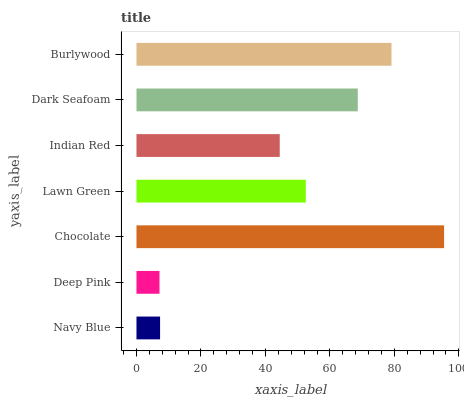Is Deep Pink the minimum?
Answer yes or no. Yes. Is Chocolate the maximum?
Answer yes or no. Yes. Is Chocolate the minimum?
Answer yes or no. No. Is Deep Pink the maximum?
Answer yes or no. No. Is Chocolate greater than Deep Pink?
Answer yes or no. Yes. Is Deep Pink less than Chocolate?
Answer yes or no. Yes. Is Deep Pink greater than Chocolate?
Answer yes or no. No. Is Chocolate less than Deep Pink?
Answer yes or no. No. Is Lawn Green the high median?
Answer yes or no. Yes. Is Lawn Green the low median?
Answer yes or no. Yes. Is Indian Red the high median?
Answer yes or no. No. Is Deep Pink the low median?
Answer yes or no. No. 